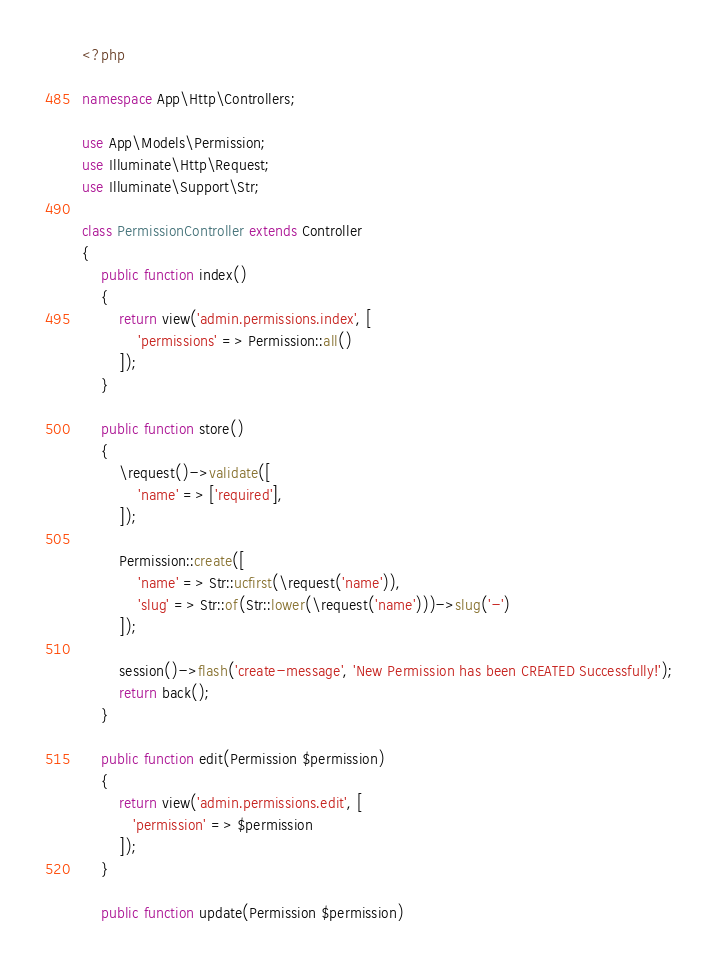Convert code to text. <code><loc_0><loc_0><loc_500><loc_500><_PHP_><?php

namespace App\Http\Controllers;

use App\Models\Permission;
use Illuminate\Http\Request;
use Illuminate\Support\Str;

class PermissionController extends Controller
{
    public function index()
    {
        return view('admin.permissions.index', [
            'permissions' => Permission::all()
        ]);
    }

    public function store()
    {
        \request()->validate([
            'name' => ['required'],
        ]);

        Permission::create([
            'name' => Str::ucfirst(\request('name')),
            'slug' => Str::of(Str::lower(\request('name')))->slug('-')
        ]);

        session()->flash('create-message', 'New Permission has been CREATED Successfully!');
        return back();
    }

    public function edit(Permission $permission)
    {
        return view('admin.permissions.edit', [
           'permission' => $permission
        ]);
    }

    public function update(Permission $permission)</code> 